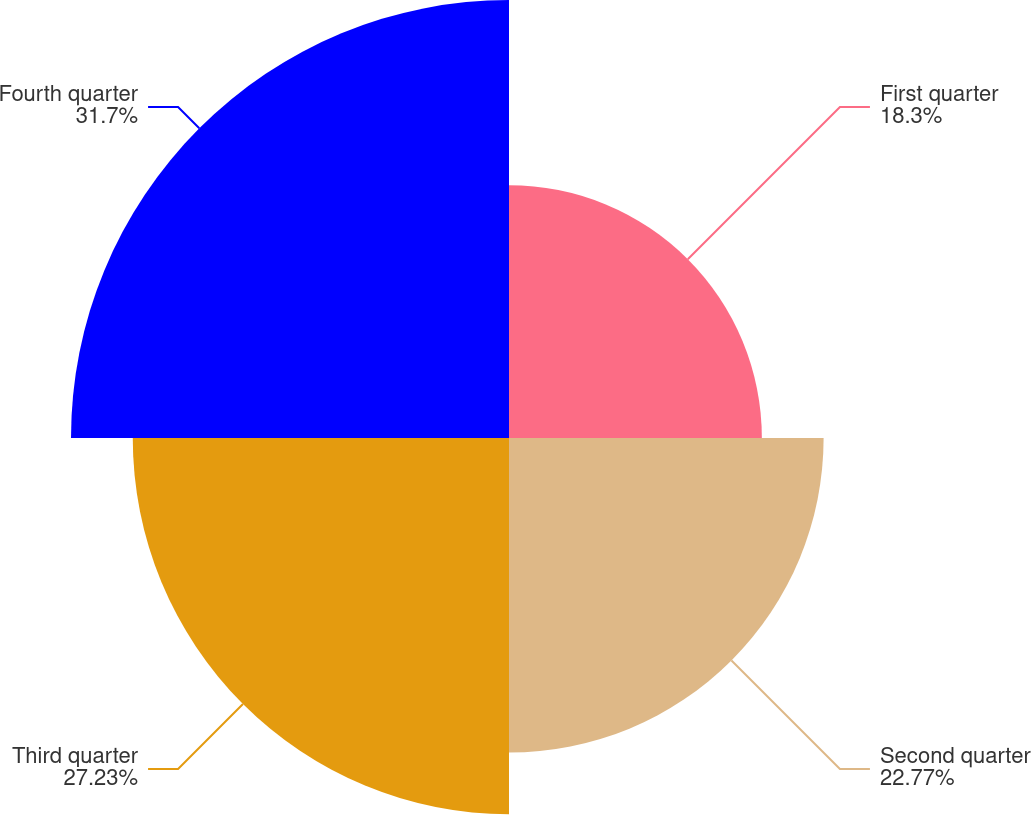Convert chart. <chart><loc_0><loc_0><loc_500><loc_500><pie_chart><fcel>First quarter<fcel>Second quarter<fcel>Third quarter<fcel>Fourth quarter<nl><fcel>18.3%<fcel>22.77%<fcel>27.23%<fcel>31.7%<nl></chart> 